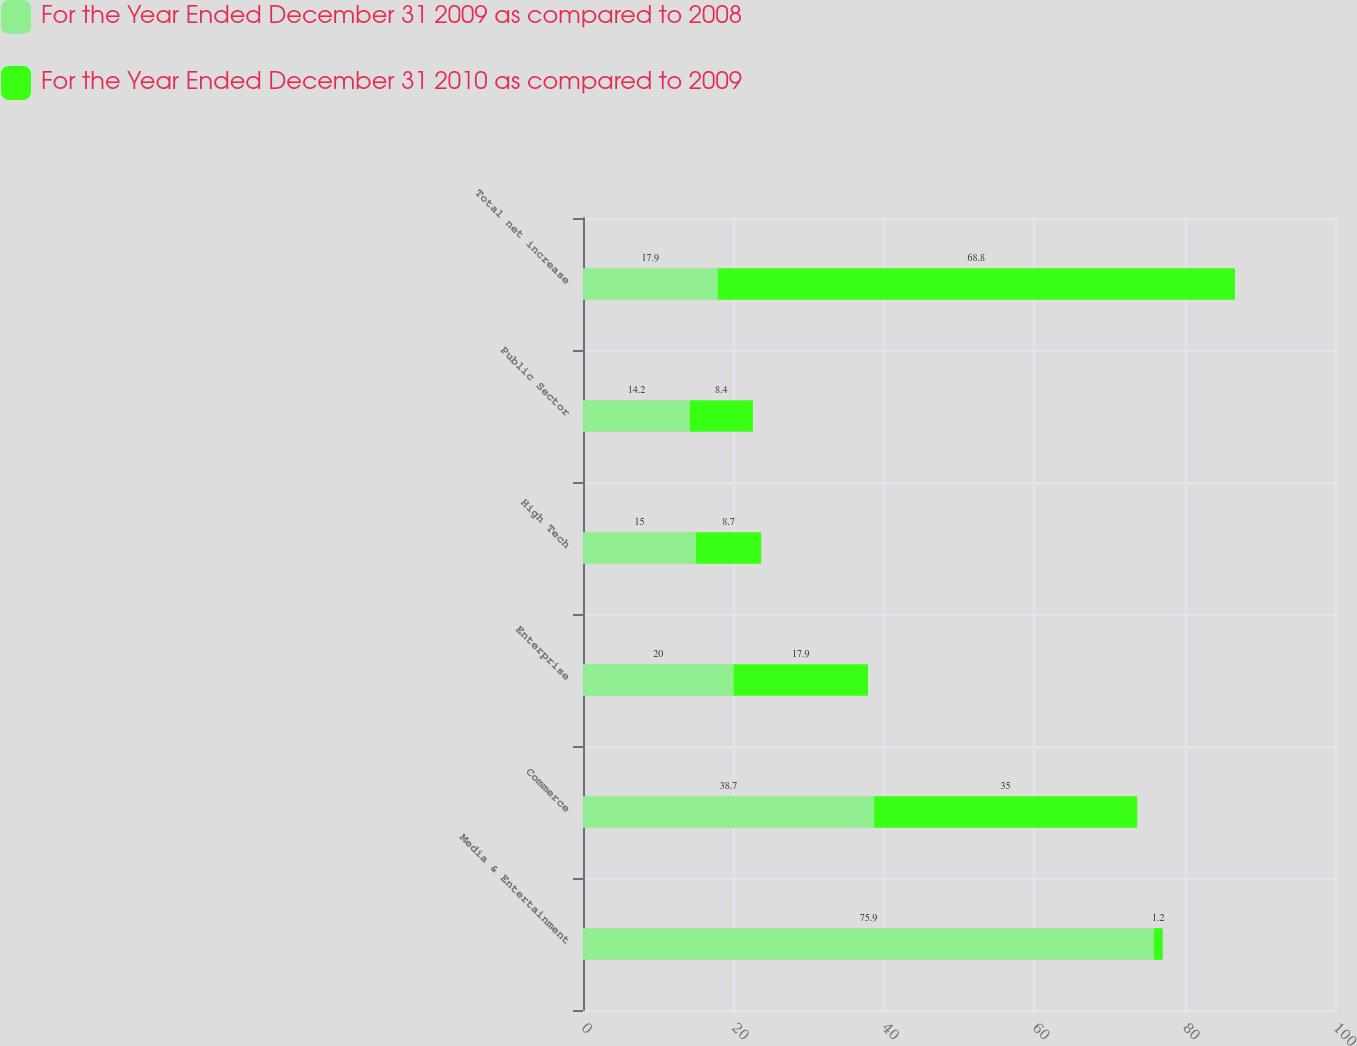Convert chart to OTSL. <chart><loc_0><loc_0><loc_500><loc_500><stacked_bar_chart><ecel><fcel>Media & Entertainment<fcel>Commerce<fcel>Enterprise<fcel>High Tech<fcel>Public Sector<fcel>Total net increase<nl><fcel>For the Year Ended December 31 2009 as compared to 2008<fcel>75.9<fcel>38.7<fcel>20<fcel>15<fcel>14.2<fcel>17.9<nl><fcel>For the Year Ended December 31 2010 as compared to 2009<fcel>1.2<fcel>35<fcel>17.9<fcel>8.7<fcel>8.4<fcel>68.8<nl></chart> 